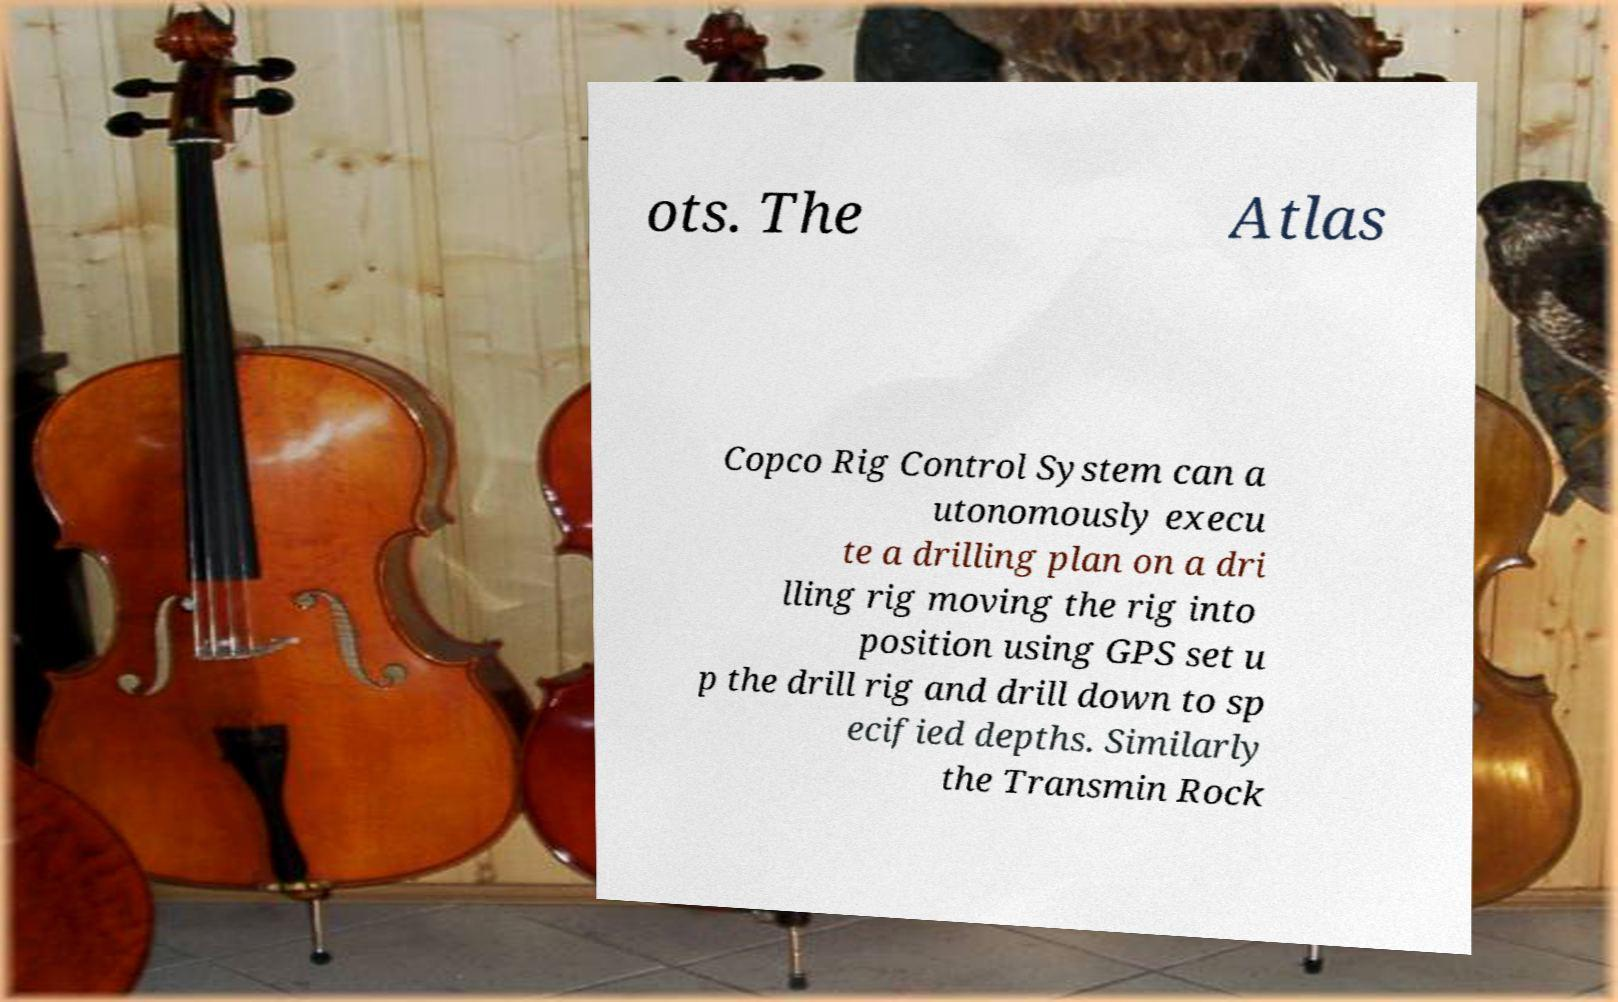What messages or text are displayed in this image? I need them in a readable, typed format. ots. The Atlas Copco Rig Control System can a utonomously execu te a drilling plan on a dri lling rig moving the rig into position using GPS set u p the drill rig and drill down to sp ecified depths. Similarly the Transmin Rock 